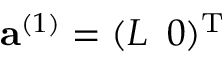Convert formula to latex. <formula><loc_0><loc_0><loc_500><loc_500>{ a } ^ { ( 1 ) } = ( L \, 0 ) ^ { T }</formula> 